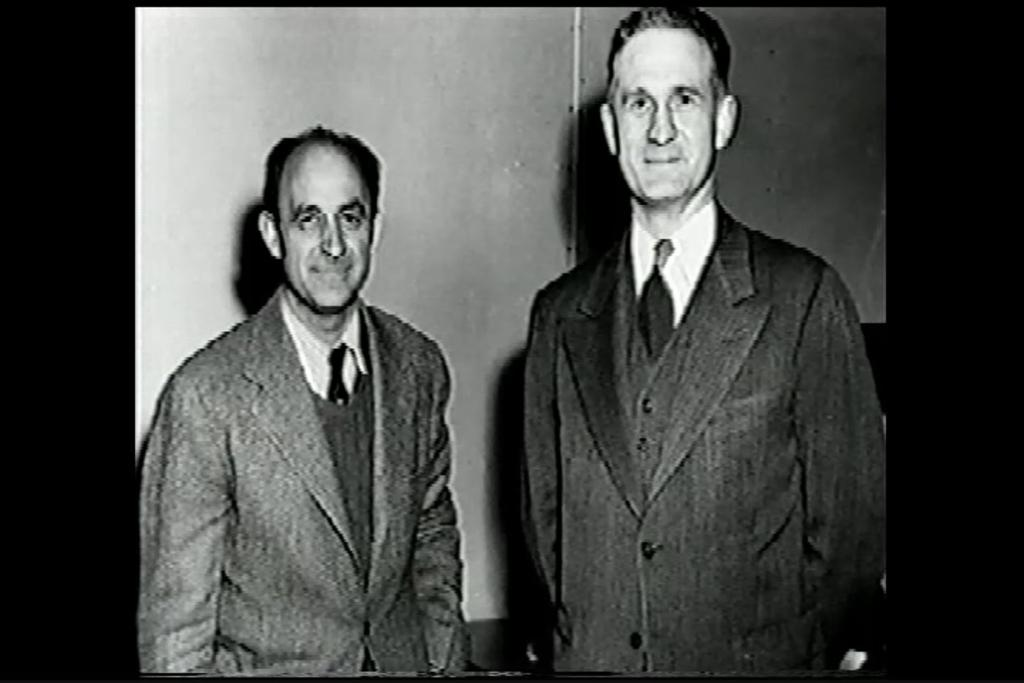How many people are in the image? There are two persons in the image. What are the persons doing in the image? The persons are standing. What type of clothing are the persons wearing? The persons are wearing blazers. What is the color scheme of the image? The image is in black and white. What type of match is being played in the image? There is no match being played in the image; it features two persons standing and wearing blazers. What kind of feast is being prepared in the image? There is no feast preparation visible in the image; it only shows two persons standing and wearing blazers. 